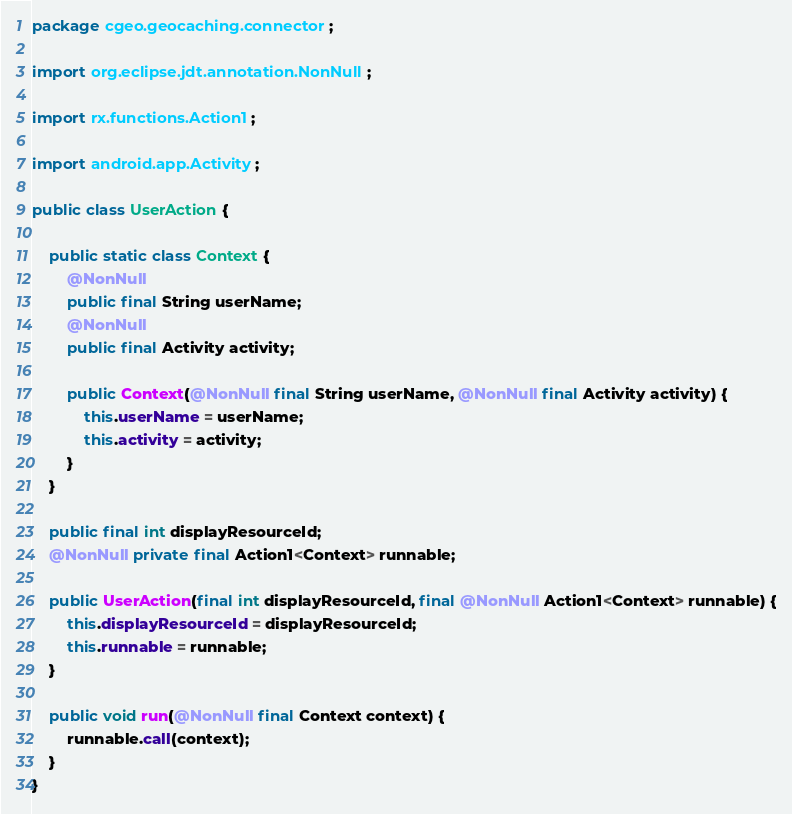Convert code to text. <code><loc_0><loc_0><loc_500><loc_500><_Java_>package cgeo.geocaching.connector;

import org.eclipse.jdt.annotation.NonNull;

import rx.functions.Action1;

import android.app.Activity;

public class UserAction {

    public static class Context {
        @NonNull
        public final String userName;
        @NonNull
        public final Activity activity;

        public Context(@NonNull final String userName, @NonNull final Activity activity) {
            this.userName = userName;
            this.activity = activity;
        }
    }

    public final int displayResourceId;
    @NonNull private final Action1<Context> runnable;

    public UserAction(final int displayResourceId, final @NonNull Action1<Context> runnable) {
        this.displayResourceId = displayResourceId;
        this.runnable = runnable;
    }

    public void run(@NonNull final Context context) {
        runnable.call(context);
    }
}
</code> 